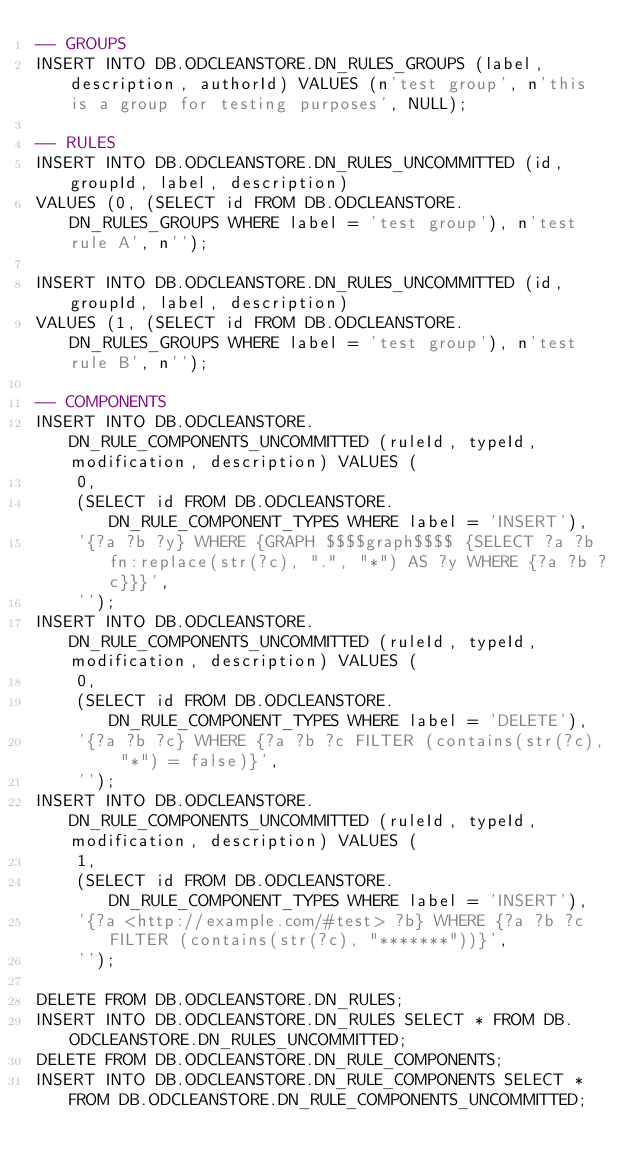<code> <loc_0><loc_0><loc_500><loc_500><_SQL_>-- GROUPS
INSERT INTO DB.ODCLEANSTORE.DN_RULES_GROUPS (label, description, authorId) VALUES (n'test group', n'this is a group for testing purposes', NULL);

-- RULES
INSERT INTO DB.ODCLEANSTORE.DN_RULES_UNCOMMITTED (id, groupId, label, description) 
VALUES (0, (SELECT id FROM DB.ODCLEANSTORE.DN_RULES_GROUPS WHERE label = 'test group'), n'test rule A', n'');

INSERT INTO DB.ODCLEANSTORE.DN_RULES_UNCOMMITTED (id, groupId, label, description) 
VALUES (1, (SELECT id FROM DB.ODCLEANSTORE.DN_RULES_GROUPS WHERE label = 'test group'), n'test rule B', n'');

-- COMPONENTS
INSERT INTO DB.ODCLEANSTORE.DN_RULE_COMPONENTS_UNCOMMITTED (ruleId, typeId, modification, description) VALUES (
	0,
	(SELECT id FROM DB.ODCLEANSTORE.DN_RULE_COMPONENT_TYPES WHERE label = 'INSERT'),
	'{?a ?b ?y} WHERE {GRAPH $$$$graph$$$$ {SELECT ?a ?b fn:replace(str(?c), ".", "*") AS ?y WHERE {?a ?b ?c}}}', 
	'');
INSERT INTO DB.ODCLEANSTORE.DN_RULE_COMPONENTS_UNCOMMITTED (ruleId, typeId, modification, description) VALUES (
	0,
	(SELECT id FROM DB.ODCLEANSTORE.DN_RULE_COMPONENT_TYPES WHERE label = 'DELETE'),
	'{?a ?b ?c} WHERE {?a ?b ?c FILTER (contains(str(?c), "*") = false)}',
	'');
INSERT INTO DB.ODCLEANSTORE.DN_RULE_COMPONENTS_UNCOMMITTED (ruleId, typeId, modification, description) VALUES (
	1,
	(SELECT id FROM DB.ODCLEANSTORE.DN_RULE_COMPONENT_TYPES WHERE label = 'INSERT'),
	'{?a <http://example.com/#test> ?b} WHERE {?a ?b ?c FILTER (contains(str(?c), "*******"))}', 
	'');

DELETE FROM DB.ODCLEANSTORE.DN_RULES;
INSERT INTO DB.ODCLEANSTORE.DN_RULES SELECT * FROM DB.ODCLEANSTORE.DN_RULES_UNCOMMITTED;
DELETE FROM DB.ODCLEANSTORE.DN_RULE_COMPONENTS;
INSERT INTO DB.ODCLEANSTORE.DN_RULE_COMPONENTS SELECT * FROM DB.ODCLEANSTORE.DN_RULE_COMPONENTS_UNCOMMITTED;

</code> 